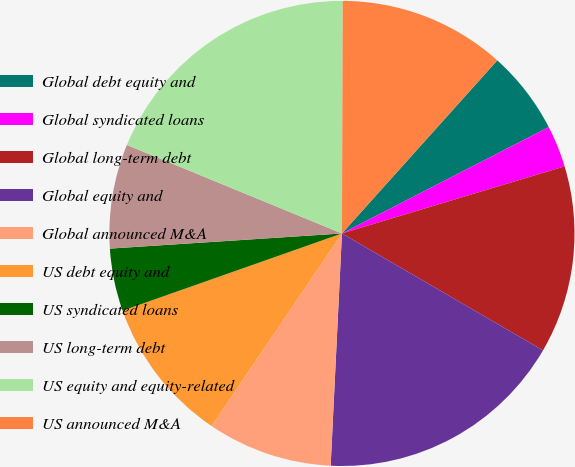<chart> <loc_0><loc_0><loc_500><loc_500><pie_chart><fcel>Global debt equity and<fcel>Global syndicated loans<fcel>Global long-term debt<fcel>Global equity and<fcel>Global announced M&A<fcel>US debt equity and<fcel>US syndicated loans<fcel>US long-term debt<fcel>US equity and equity-related<fcel>US announced M&A<nl><fcel>5.8%<fcel>2.9%<fcel>13.04%<fcel>17.39%<fcel>8.7%<fcel>10.14%<fcel>4.35%<fcel>7.25%<fcel>18.84%<fcel>11.59%<nl></chart> 